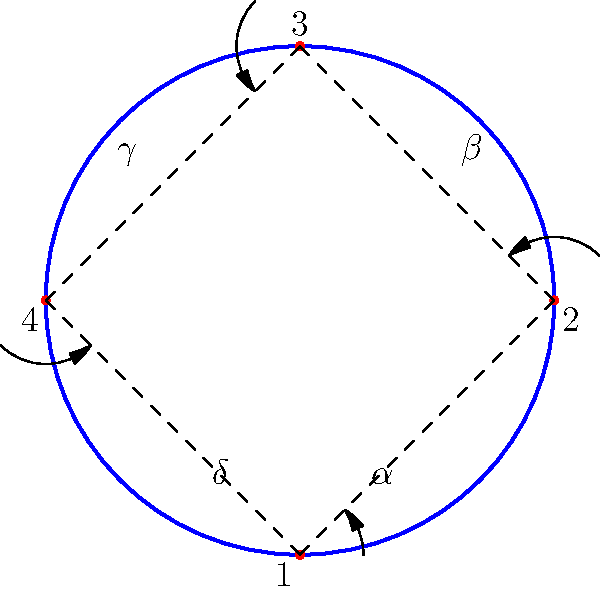In the diagram showing the rotation sequence of a discus throw, which angle represents the critical moment of release for maximum distance, assuming ideal conditions? To determine the critical angle for maximum distance in a discus throw, we need to consider the following steps:

1. The diagram shows a complete rotation sequence of a discus throw, divided into four main positions (1, 2, 3, and 4).

2. Each position is associated with an angle ($\alpha$, $\beta$, $\gamma$, and $\delta$).

3. In discus throwing, the release angle is crucial for achieving maximum distance. The ideal release angle is typically between 35-44 degrees, depending on various factors such as wind speed and the thrower's technique.

4. Analyzing the diagram:
   - $\alpha$ represents the initial wind-up phase
   - $\beta$ shows the acceleration phase
   - $\gamma$ indicates the moment just before release
   - $\delta$ represents the follow-through phase

5. The critical moment for release occurs at the transition between positions 3 and 4, which is represented by angle $\gamma$.

6. At this point (angle $\gamma$), the discus has reached its maximum velocity, and the thrower's body is in the optimal position to impart the final acceleration and release the discus at the ideal angle.

Therefore, angle $\gamma$ represents the critical moment of release for maximum distance in the discus throw.
Answer: $\gamma$ 